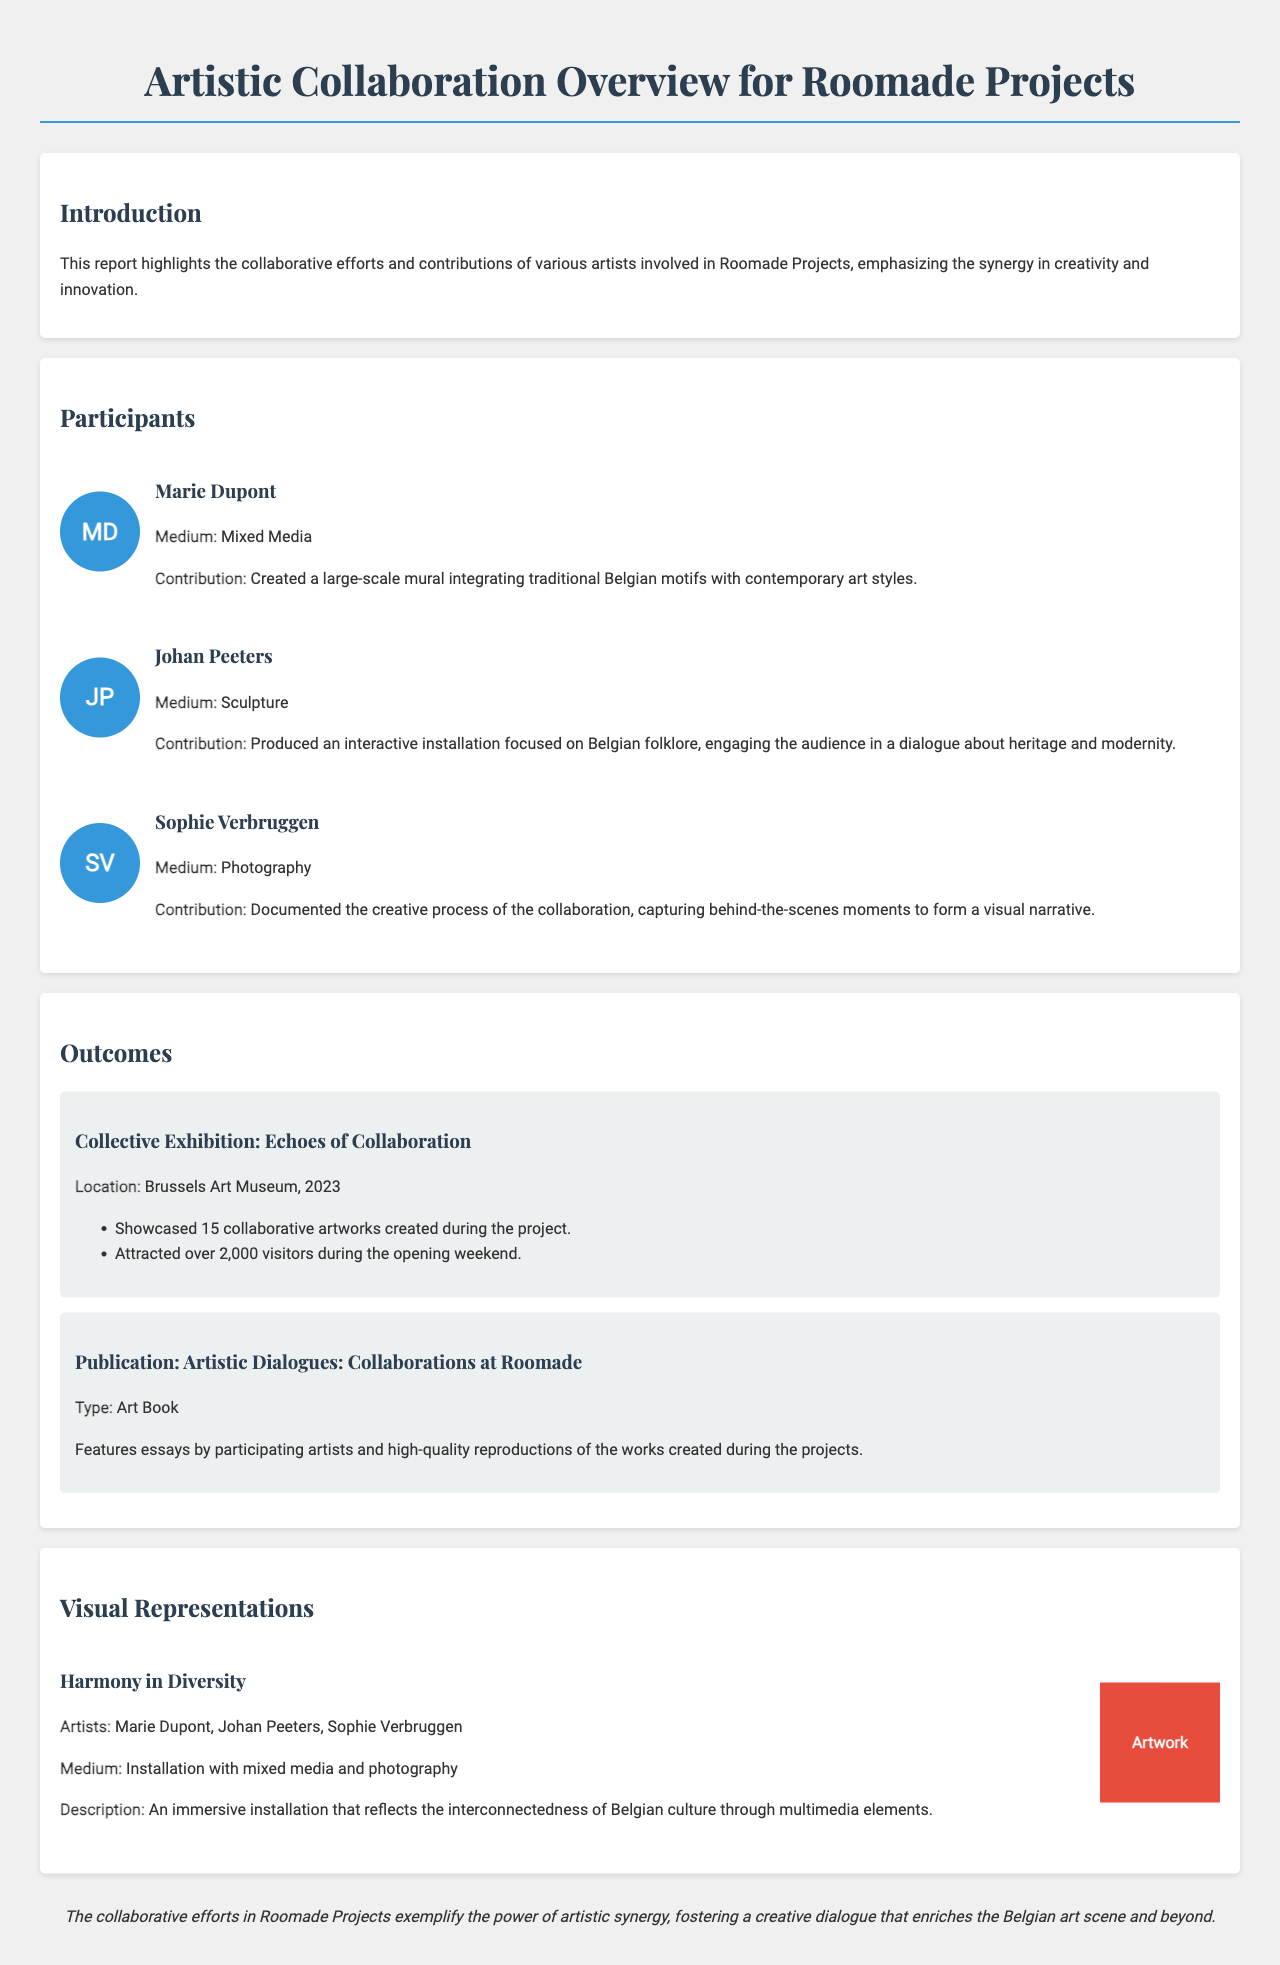What is the title of the report? The title of the report is prominently displayed at the top of the document.
Answer: Artistic Collaboration Overview for Roomade Projects Who created the large-scale mural? Marie Dupont is credited with creating the large-scale mural in the document.
Answer: Marie Dupont What was the location of the collective exhibition? The location of the collective exhibition is mentioned in the outcomes section of the document.
Answer: Brussels Art Museum How many visitors attended the opening weekend of the exhibition? The document states that over 2,000 visitors attended during the opening weekend.
Answer: 2,000 What medium did Johan Peeters use for his contribution? Johan Peeters' medium is specified within his participant information.
Answer: Sculpture What is the title of the publication mentioned in the outcomes? The outcomes section contains the title of the publication featuring essays by artists.
Answer: Artistic Dialogues: Collaborations at Roomade How many collaborative artworks were showcased in the exhibition? The document indicates that 15 collaborative artworks were showcased during the exhibition.
Answer: 15 Which three artists collaborated on the artwork "Harmony in Diversity"? The document lists the artists involved in this specific artwork as part of the visual representations section.
Answer: Marie Dupont, Johan Peeters, Sophie Verbruggen 